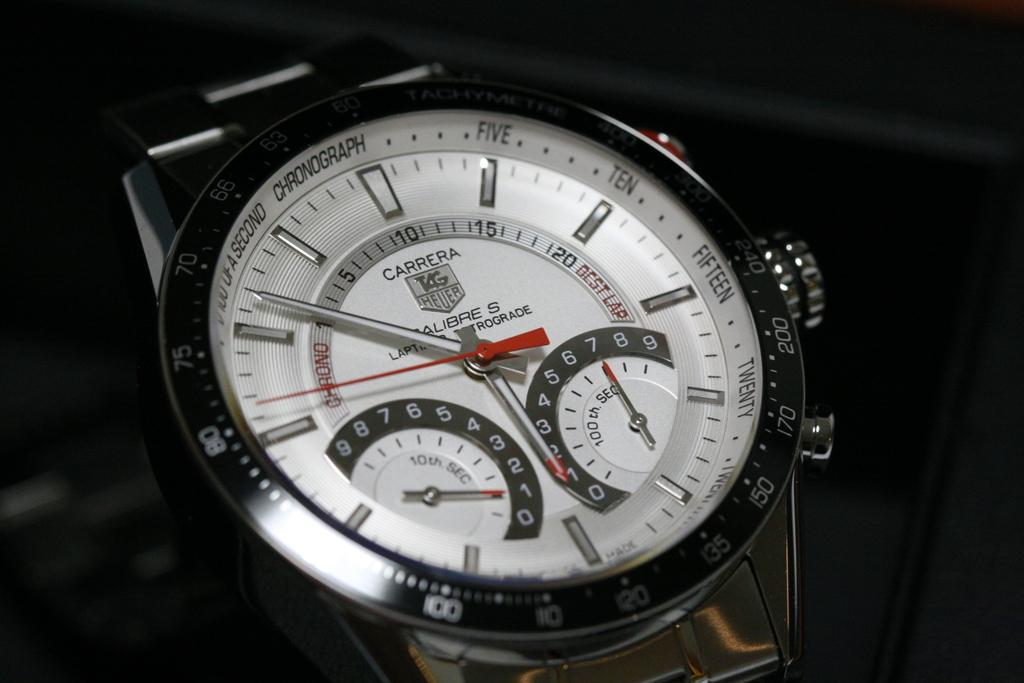<image>
Give a short and clear explanation of the subsequent image. A silver Carrera TAG Heuer watch on display. 